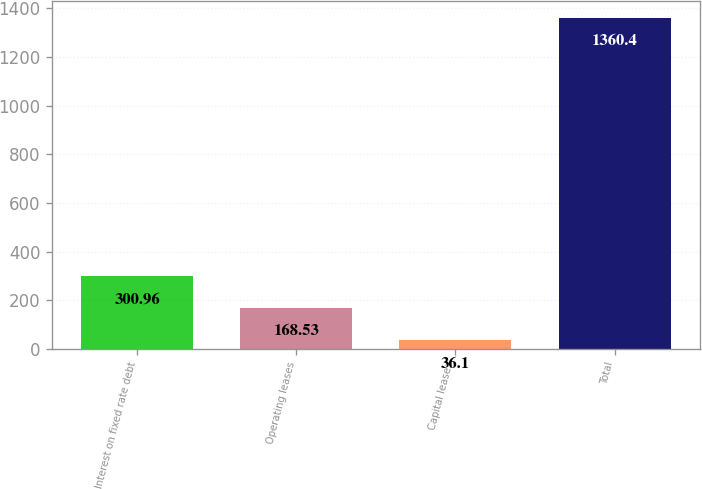<chart> <loc_0><loc_0><loc_500><loc_500><bar_chart><fcel>Interest on fixed rate debt<fcel>Operating leases<fcel>Capital leases<fcel>Total<nl><fcel>300.96<fcel>168.53<fcel>36.1<fcel>1360.4<nl></chart> 